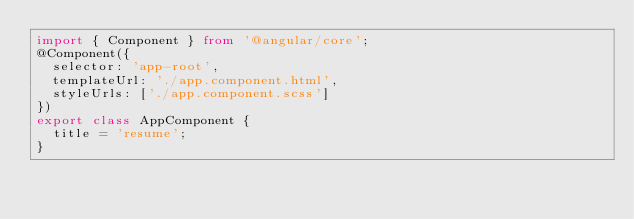Convert code to text. <code><loc_0><loc_0><loc_500><loc_500><_TypeScript_>import { Component } from '@angular/core';
@Component({
  selector: 'app-root',
  templateUrl: './app.component.html',
  styleUrls: ['./app.component.scss']
})
export class AppComponent {
  title = 'resume';
}
</code> 